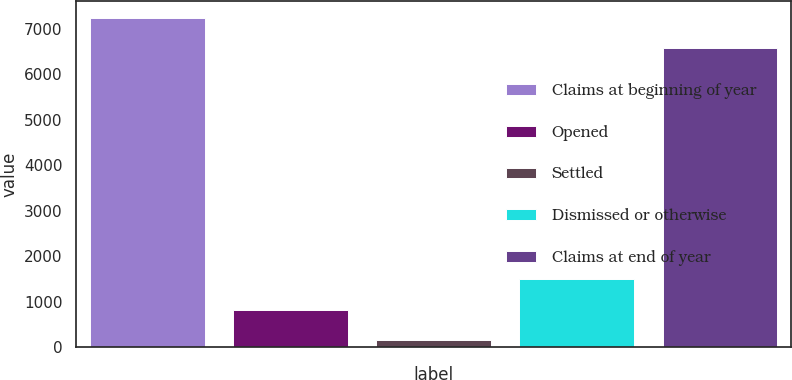Convert chart to OTSL. <chart><loc_0><loc_0><loc_500><loc_500><bar_chart><fcel>Claims at beginning of year<fcel>Opened<fcel>Settled<fcel>Dismissed or otherwise<fcel>Claims at end of year<nl><fcel>7235.8<fcel>822.8<fcel>150<fcel>1495.6<fcel>6563<nl></chart> 